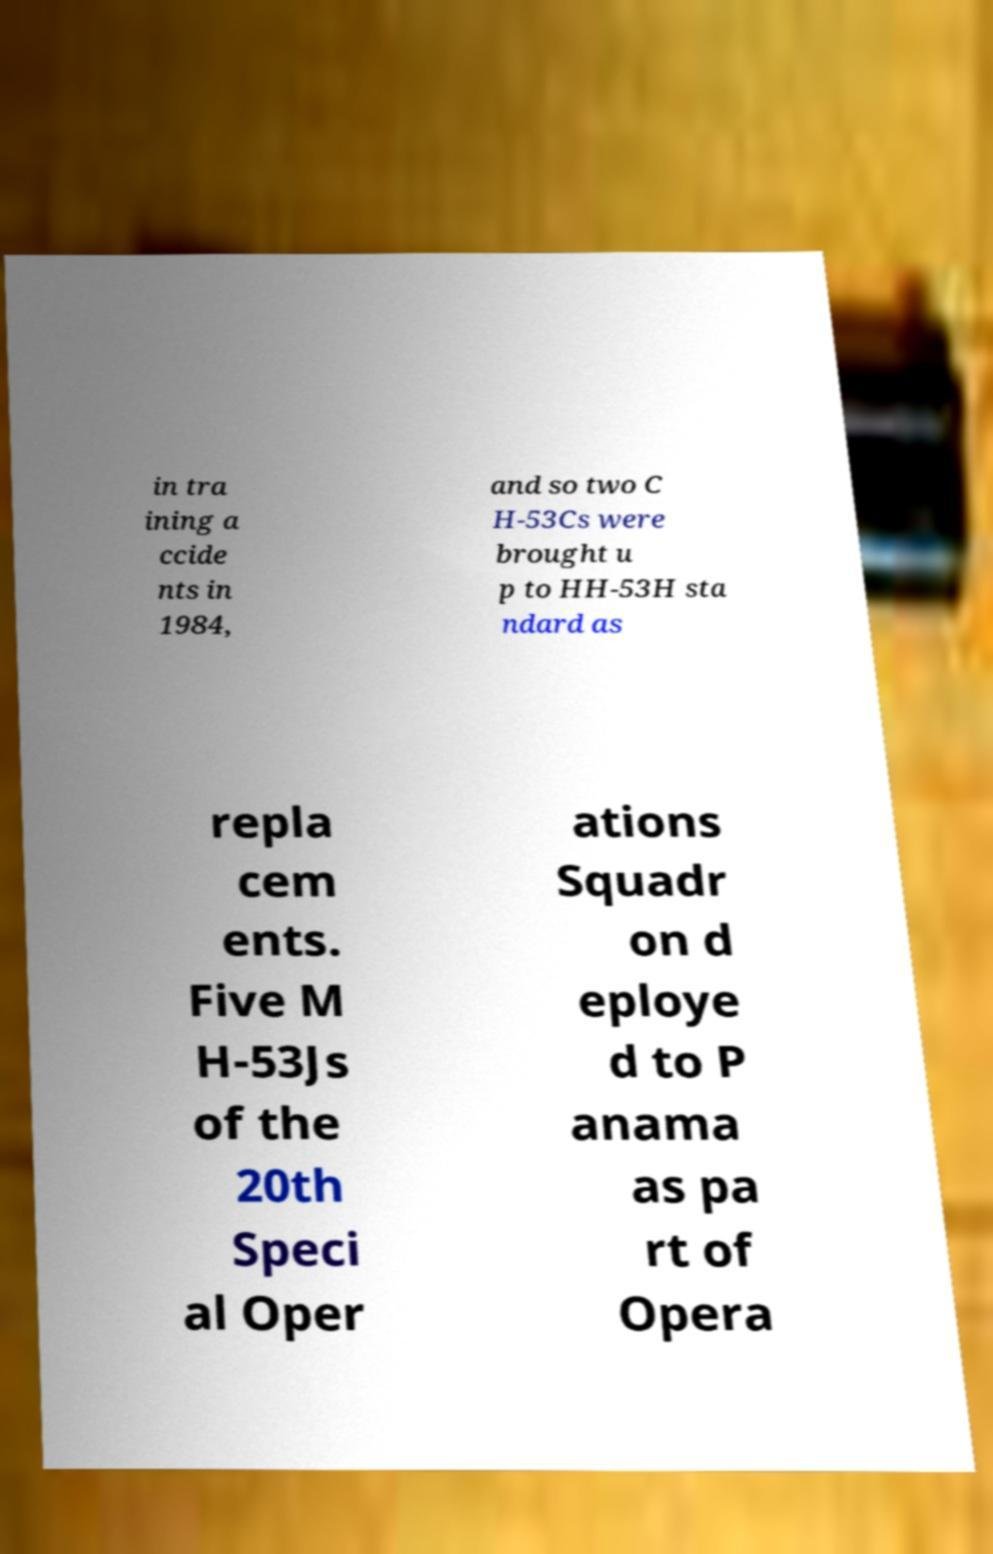Can you read and provide the text displayed in the image?This photo seems to have some interesting text. Can you extract and type it out for me? in tra ining a ccide nts in 1984, and so two C H-53Cs were brought u p to HH-53H sta ndard as repla cem ents. Five M H-53Js of the 20th Speci al Oper ations Squadr on d eploye d to P anama as pa rt of Opera 